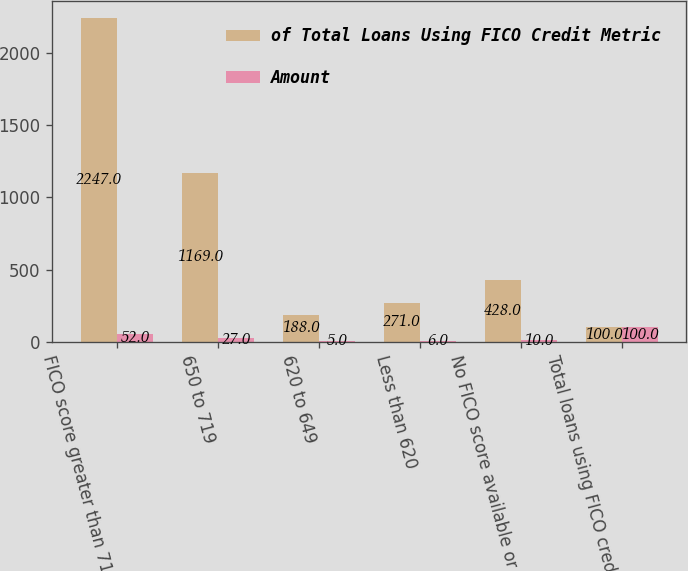<chart> <loc_0><loc_0><loc_500><loc_500><stacked_bar_chart><ecel><fcel>FICO score greater than 719<fcel>650 to 719<fcel>620 to 649<fcel>Less than 620<fcel>No FICO score available or<fcel>Total loans using FICO credit<nl><fcel>of Total Loans Using FICO Credit Metric<fcel>2247<fcel>1169<fcel>188<fcel>271<fcel>428<fcel>100<nl><fcel>Amount<fcel>52<fcel>27<fcel>5<fcel>6<fcel>10<fcel>100<nl></chart> 